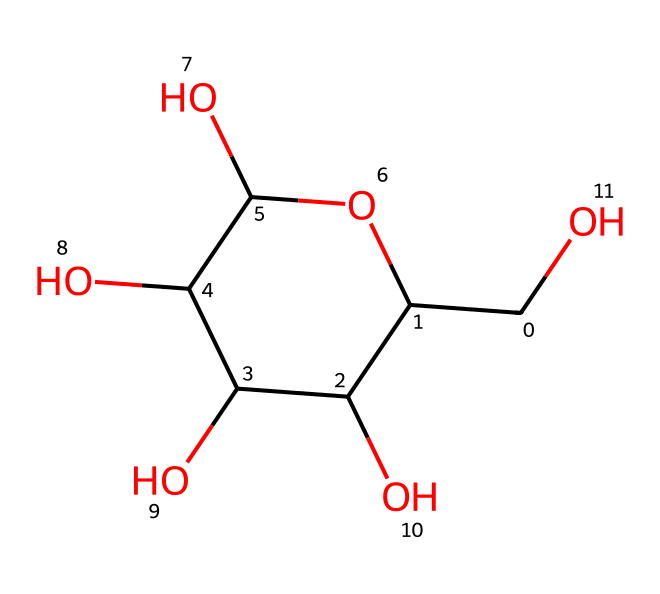What is the molecular formula of this sugar? To determine the molecular formula, count the number of each type of atom in the structure. There are 6 carbon (C) atoms, 12 hydrogen (H) atoms, and 6 oxygen (O) atoms, giving us C6H12O6.
Answer: C6H12O6 How many hydroxyl (–OH) groups are present in this chemical structure? By examining the structure, we can identify the hydroxyl groups as-OH parts. In this molecule, there are 5 hydroxyl groups present.
Answer: 5 What functional groups are present in glucose? The primary functional groups in glucose include aldehyde (as it's an aldose) and multiple hydroxyl (-OH) groups. The aldehyde is indicated by the presence of a carbonyl carbon at one end.
Answer: aldehyde and hydroxyl groups What type of isomer is glucose in this structure? Glucose can exist as several isomers; however, in this specific structure, it is in the form of a cyclic hemiacetal, which occurs when the aldehyde group reacts with an alcohol group.
Answer: cyclic hemiacetal Is glucose a reducing sugar? Yes, glucose is a reducing sugar due to its free aldehyde group that can reduce other substances by donating electrons.
Answer: yes What is the characteristic property of glucose related to solubility? Glucose is highly soluble in water due to its multiple hydroxyl groups which can form hydrogen bonds with water molecules.
Answer: highly soluble 